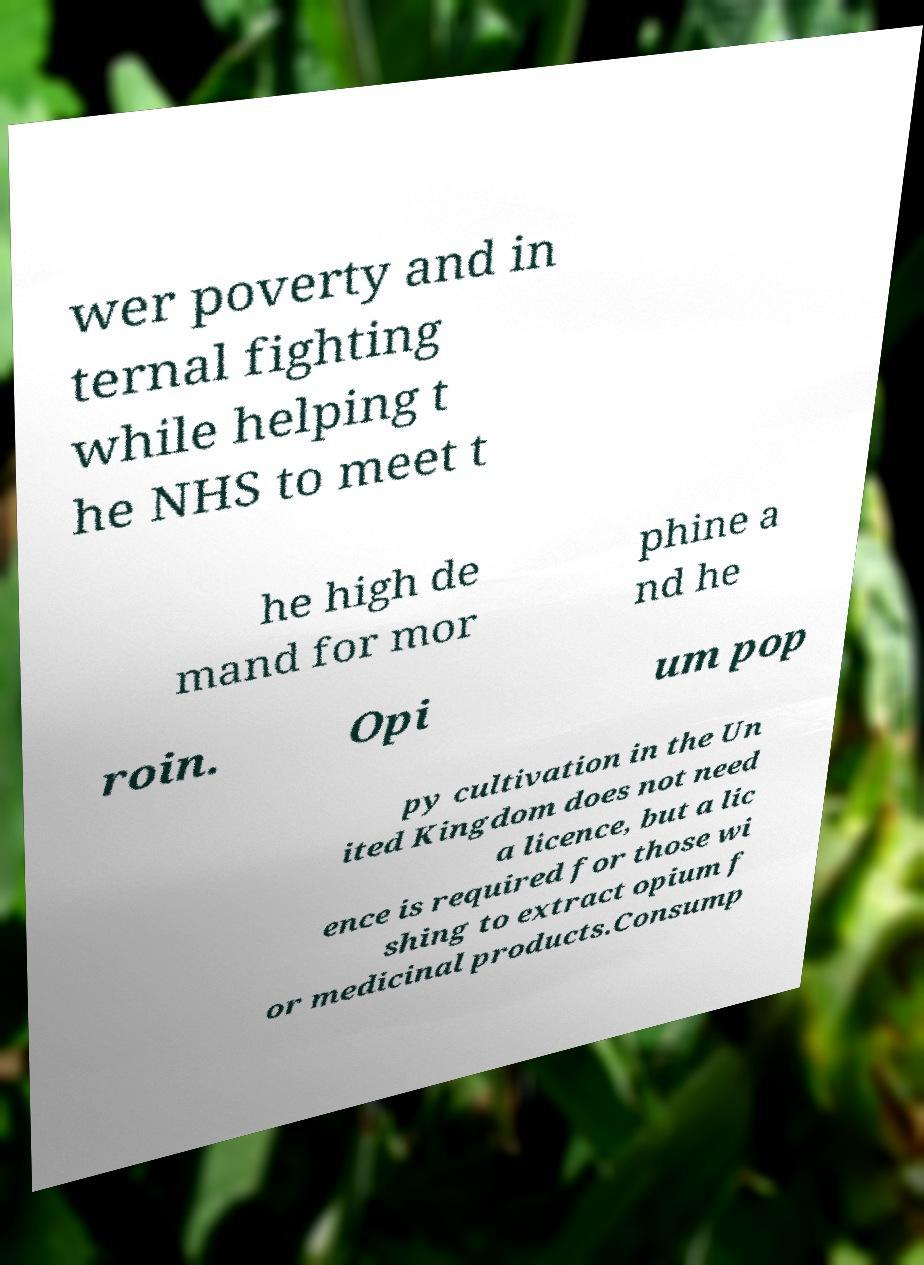Could you assist in decoding the text presented in this image and type it out clearly? wer poverty and in ternal fighting while helping t he NHS to meet t he high de mand for mor phine a nd he roin. Opi um pop py cultivation in the Un ited Kingdom does not need a licence, but a lic ence is required for those wi shing to extract opium f or medicinal products.Consump 